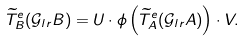Convert formula to latex. <formula><loc_0><loc_0><loc_500><loc_500>& \widetilde { T } ^ { e } _ { B } ( \mathcal { G } _ { l r } B ) = U \cdot \phi \left ( \widetilde { T } ^ { e } _ { A } ( \mathcal { G } _ { l r } A ) \right ) \cdot V .</formula> 